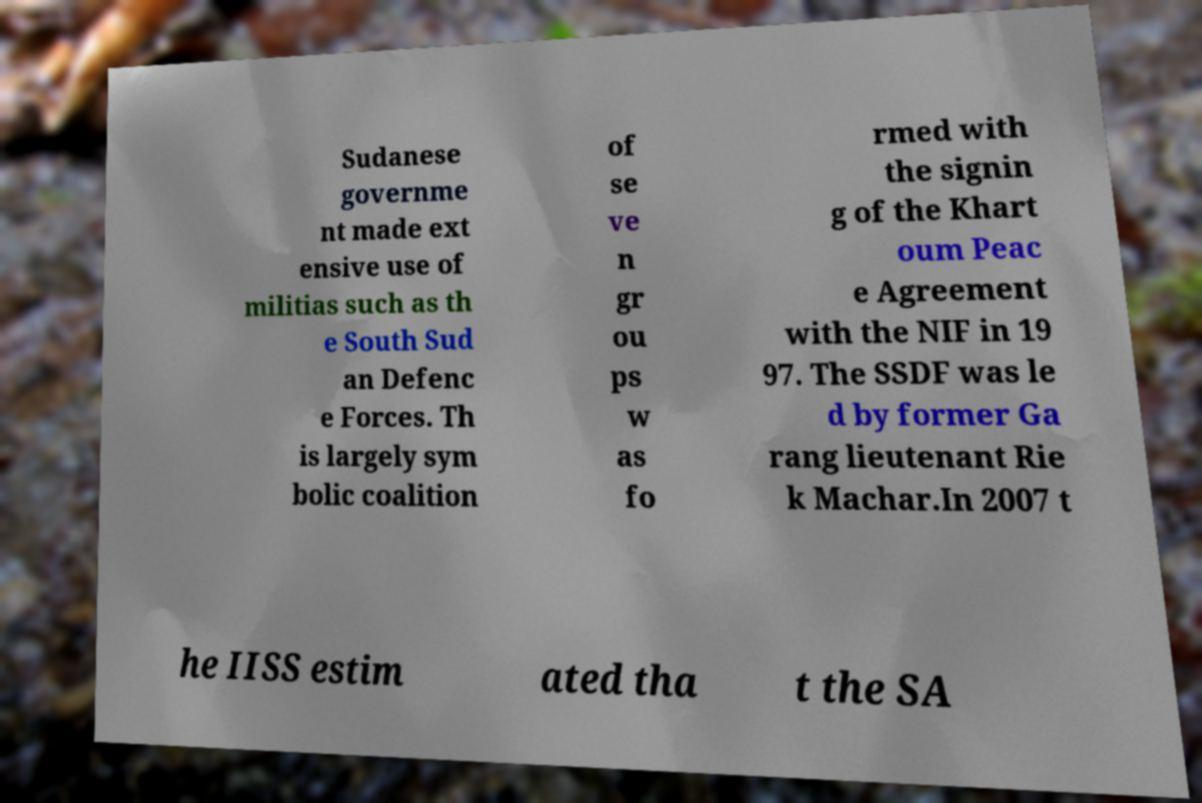There's text embedded in this image that I need extracted. Can you transcribe it verbatim? Sudanese governme nt made ext ensive use of militias such as th e South Sud an Defenc e Forces. Th is largely sym bolic coalition of se ve n gr ou ps w as fo rmed with the signin g of the Khart oum Peac e Agreement with the NIF in 19 97. The SSDF was le d by former Ga rang lieutenant Rie k Machar.In 2007 t he IISS estim ated tha t the SA 